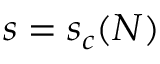<formula> <loc_0><loc_0><loc_500><loc_500>s = s _ { c } ( N )</formula> 